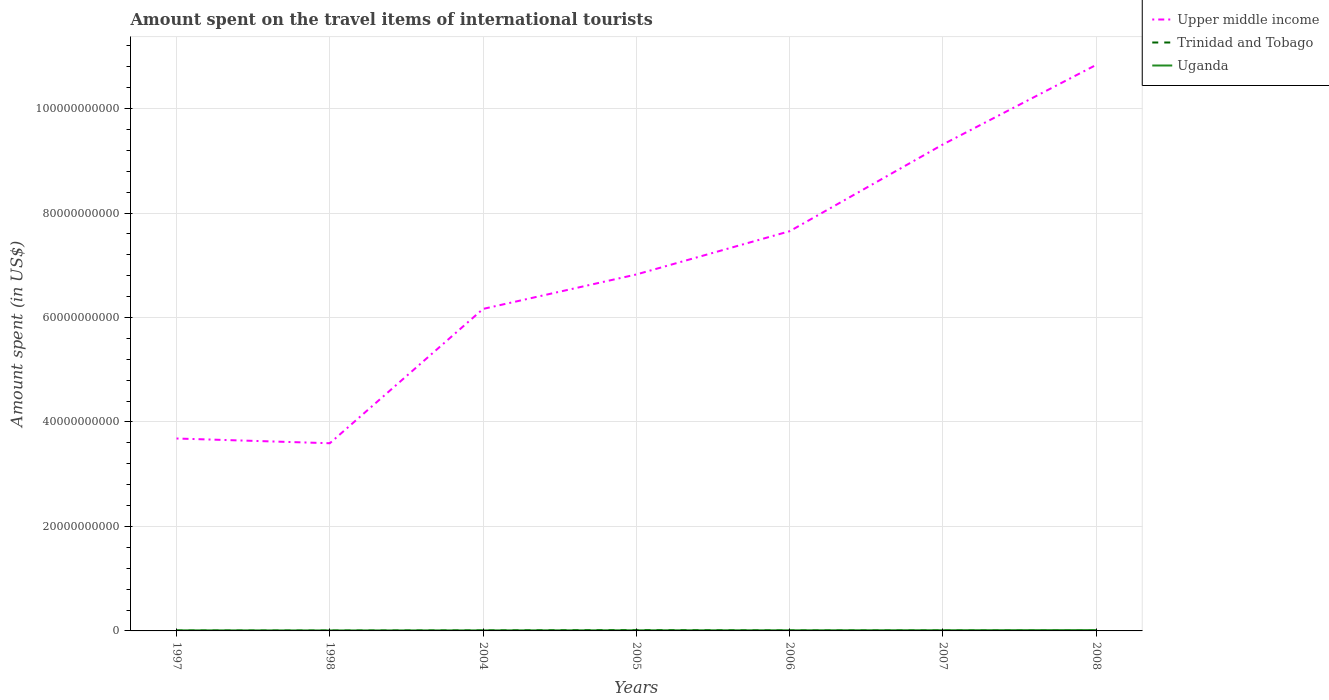Does the line corresponding to Trinidad and Tobago intersect with the line corresponding to Upper middle income?
Your response must be concise. No. Across all years, what is the maximum amount spent on the travel items of international tourists in Upper middle income?
Ensure brevity in your answer.  3.59e+1. In which year was the amount spent on the travel items of international tourists in Uganda maximum?
Your answer should be very brief. 1998. What is the total amount spent on the travel items of international tourists in Upper middle income in the graph?
Your answer should be compact. -5.72e+1. What is the difference between the highest and the second highest amount spent on the travel items of international tourists in Upper middle income?
Your answer should be compact. 7.24e+1. What is the difference between the highest and the lowest amount spent on the travel items of international tourists in Upper middle income?
Provide a short and direct response. 3. Is the amount spent on the travel items of international tourists in Uganda strictly greater than the amount spent on the travel items of international tourists in Upper middle income over the years?
Ensure brevity in your answer.  Yes. How many lines are there?
Your answer should be very brief. 3. Are the values on the major ticks of Y-axis written in scientific E-notation?
Your answer should be compact. No. Where does the legend appear in the graph?
Provide a succinct answer. Top right. What is the title of the graph?
Your response must be concise. Amount spent on the travel items of international tourists. Does "Luxembourg" appear as one of the legend labels in the graph?
Your answer should be very brief. No. What is the label or title of the Y-axis?
Give a very brief answer. Amount spent (in US$). What is the Amount spent (in US$) in Upper middle income in 1997?
Your answer should be very brief. 3.68e+1. What is the Amount spent (in US$) in Trinidad and Tobago in 1997?
Ensure brevity in your answer.  7.20e+07. What is the Amount spent (in US$) in Uganda in 1997?
Keep it short and to the point. 1.13e+08. What is the Amount spent (in US$) of Upper middle income in 1998?
Provide a short and direct response. 3.59e+1. What is the Amount spent (in US$) of Trinidad and Tobago in 1998?
Give a very brief answer. 6.70e+07. What is the Amount spent (in US$) of Uganda in 1998?
Offer a terse response. 9.50e+07. What is the Amount spent (in US$) of Upper middle income in 2004?
Keep it short and to the point. 6.16e+1. What is the Amount spent (in US$) in Trinidad and Tobago in 2004?
Ensure brevity in your answer.  9.60e+07. What is the Amount spent (in US$) in Uganda in 2004?
Your answer should be compact. 1.08e+08. What is the Amount spent (in US$) in Upper middle income in 2005?
Offer a terse response. 6.82e+1. What is the Amount spent (in US$) of Trinidad and Tobago in 2005?
Make the answer very short. 1.80e+08. What is the Amount spent (in US$) in Uganda in 2005?
Your answer should be compact. 1.24e+08. What is the Amount spent (in US$) in Upper middle income in 2006?
Your response must be concise. 7.65e+1. What is the Amount spent (in US$) of Trinidad and Tobago in 2006?
Make the answer very short. 9.30e+07. What is the Amount spent (in US$) of Uganda in 2006?
Your answer should be compact. 1.23e+08. What is the Amount spent (in US$) of Upper middle income in 2007?
Provide a succinct answer. 9.31e+1. What is the Amount spent (in US$) in Trinidad and Tobago in 2007?
Give a very brief answer. 9.40e+07. What is the Amount spent (in US$) of Uganda in 2007?
Offer a very short reply. 1.32e+08. What is the Amount spent (in US$) of Upper middle income in 2008?
Keep it short and to the point. 1.08e+11. What is the Amount spent (in US$) of Trinidad and Tobago in 2008?
Your answer should be compact. 7.50e+07. What is the Amount spent (in US$) in Uganda in 2008?
Your answer should be very brief. 1.56e+08. Across all years, what is the maximum Amount spent (in US$) of Upper middle income?
Your answer should be very brief. 1.08e+11. Across all years, what is the maximum Amount spent (in US$) of Trinidad and Tobago?
Keep it short and to the point. 1.80e+08. Across all years, what is the maximum Amount spent (in US$) of Uganda?
Your answer should be compact. 1.56e+08. Across all years, what is the minimum Amount spent (in US$) of Upper middle income?
Your answer should be very brief. 3.59e+1. Across all years, what is the minimum Amount spent (in US$) of Trinidad and Tobago?
Keep it short and to the point. 6.70e+07. Across all years, what is the minimum Amount spent (in US$) of Uganda?
Your response must be concise. 9.50e+07. What is the total Amount spent (in US$) in Upper middle income in the graph?
Offer a terse response. 4.81e+11. What is the total Amount spent (in US$) of Trinidad and Tobago in the graph?
Provide a short and direct response. 6.77e+08. What is the total Amount spent (in US$) in Uganda in the graph?
Provide a succinct answer. 8.51e+08. What is the difference between the Amount spent (in US$) of Upper middle income in 1997 and that in 1998?
Offer a terse response. 9.09e+08. What is the difference between the Amount spent (in US$) of Trinidad and Tobago in 1997 and that in 1998?
Provide a short and direct response. 5.00e+06. What is the difference between the Amount spent (in US$) of Uganda in 1997 and that in 1998?
Provide a succinct answer. 1.80e+07. What is the difference between the Amount spent (in US$) of Upper middle income in 1997 and that in 2004?
Give a very brief answer. -2.48e+1. What is the difference between the Amount spent (in US$) in Trinidad and Tobago in 1997 and that in 2004?
Provide a succinct answer. -2.40e+07. What is the difference between the Amount spent (in US$) in Uganda in 1997 and that in 2004?
Your answer should be very brief. 5.00e+06. What is the difference between the Amount spent (in US$) of Upper middle income in 1997 and that in 2005?
Ensure brevity in your answer.  -3.14e+1. What is the difference between the Amount spent (in US$) of Trinidad and Tobago in 1997 and that in 2005?
Provide a short and direct response. -1.08e+08. What is the difference between the Amount spent (in US$) of Uganda in 1997 and that in 2005?
Offer a terse response. -1.10e+07. What is the difference between the Amount spent (in US$) of Upper middle income in 1997 and that in 2006?
Ensure brevity in your answer.  -3.97e+1. What is the difference between the Amount spent (in US$) of Trinidad and Tobago in 1997 and that in 2006?
Make the answer very short. -2.10e+07. What is the difference between the Amount spent (in US$) of Uganda in 1997 and that in 2006?
Offer a very short reply. -1.00e+07. What is the difference between the Amount spent (in US$) in Upper middle income in 1997 and that in 2007?
Ensure brevity in your answer.  -5.63e+1. What is the difference between the Amount spent (in US$) in Trinidad and Tobago in 1997 and that in 2007?
Your response must be concise. -2.20e+07. What is the difference between the Amount spent (in US$) of Uganda in 1997 and that in 2007?
Keep it short and to the point. -1.90e+07. What is the difference between the Amount spent (in US$) of Upper middle income in 1997 and that in 2008?
Your answer should be very brief. -7.15e+1. What is the difference between the Amount spent (in US$) of Trinidad and Tobago in 1997 and that in 2008?
Ensure brevity in your answer.  -3.00e+06. What is the difference between the Amount spent (in US$) of Uganda in 1997 and that in 2008?
Your answer should be very brief. -4.30e+07. What is the difference between the Amount spent (in US$) in Upper middle income in 1998 and that in 2004?
Give a very brief answer. -2.57e+1. What is the difference between the Amount spent (in US$) of Trinidad and Tobago in 1998 and that in 2004?
Make the answer very short. -2.90e+07. What is the difference between the Amount spent (in US$) in Uganda in 1998 and that in 2004?
Make the answer very short. -1.30e+07. What is the difference between the Amount spent (in US$) in Upper middle income in 1998 and that in 2005?
Offer a terse response. -3.23e+1. What is the difference between the Amount spent (in US$) in Trinidad and Tobago in 1998 and that in 2005?
Your answer should be very brief. -1.13e+08. What is the difference between the Amount spent (in US$) of Uganda in 1998 and that in 2005?
Offer a very short reply. -2.90e+07. What is the difference between the Amount spent (in US$) of Upper middle income in 1998 and that in 2006?
Give a very brief answer. -4.06e+1. What is the difference between the Amount spent (in US$) in Trinidad and Tobago in 1998 and that in 2006?
Provide a succinct answer. -2.60e+07. What is the difference between the Amount spent (in US$) of Uganda in 1998 and that in 2006?
Give a very brief answer. -2.80e+07. What is the difference between the Amount spent (in US$) in Upper middle income in 1998 and that in 2007?
Your answer should be compact. -5.72e+1. What is the difference between the Amount spent (in US$) in Trinidad and Tobago in 1998 and that in 2007?
Keep it short and to the point. -2.70e+07. What is the difference between the Amount spent (in US$) in Uganda in 1998 and that in 2007?
Give a very brief answer. -3.70e+07. What is the difference between the Amount spent (in US$) in Upper middle income in 1998 and that in 2008?
Your response must be concise. -7.24e+1. What is the difference between the Amount spent (in US$) in Trinidad and Tobago in 1998 and that in 2008?
Your response must be concise. -8.00e+06. What is the difference between the Amount spent (in US$) in Uganda in 1998 and that in 2008?
Provide a short and direct response. -6.10e+07. What is the difference between the Amount spent (in US$) in Upper middle income in 2004 and that in 2005?
Provide a short and direct response. -6.59e+09. What is the difference between the Amount spent (in US$) of Trinidad and Tobago in 2004 and that in 2005?
Make the answer very short. -8.40e+07. What is the difference between the Amount spent (in US$) of Uganda in 2004 and that in 2005?
Offer a very short reply. -1.60e+07. What is the difference between the Amount spent (in US$) of Upper middle income in 2004 and that in 2006?
Offer a very short reply. -1.49e+1. What is the difference between the Amount spent (in US$) in Uganda in 2004 and that in 2006?
Give a very brief answer. -1.50e+07. What is the difference between the Amount spent (in US$) of Upper middle income in 2004 and that in 2007?
Your answer should be very brief. -3.15e+1. What is the difference between the Amount spent (in US$) of Uganda in 2004 and that in 2007?
Provide a short and direct response. -2.40e+07. What is the difference between the Amount spent (in US$) in Upper middle income in 2004 and that in 2008?
Offer a very short reply. -4.67e+1. What is the difference between the Amount spent (in US$) in Trinidad and Tobago in 2004 and that in 2008?
Your response must be concise. 2.10e+07. What is the difference between the Amount spent (in US$) of Uganda in 2004 and that in 2008?
Offer a very short reply. -4.80e+07. What is the difference between the Amount spent (in US$) of Upper middle income in 2005 and that in 2006?
Provide a succinct answer. -8.28e+09. What is the difference between the Amount spent (in US$) in Trinidad and Tobago in 2005 and that in 2006?
Ensure brevity in your answer.  8.70e+07. What is the difference between the Amount spent (in US$) in Uganda in 2005 and that in 2006?
Your response must be concise. 1.00e+06. What is the difference between the Amount spent (in US$) of Upper middle income in 2005 and that in 2007?
Offer a terse response. -2.49e+1. What is the difference between the Amount spent (in US$) in Trinidad and Tobago in 2005 and that in 2007?
Give a very brief answer. 8.60e+07. What is the difference between the Amount spent (in US$) of Uganda in 2005 and that in 2007?
Give a very brief answer. -8.00e+06. What is the difference between the Amount spent (in US$) in Upper middle income in 2005 and that in 2008?
Your answer should be compact. -4.01e+1. What is the difference between the Amount spent (in US$) of Trinidad and Tobago in 2005 and that in 2008?
Your answer should be compact. 1.05e+08. What is the difference between the Amount spent (in US$) of Uganda in 2005 and that in 2008?
Your response must be concise. -3.20e+07. What is the difference between the Amount spent (in US$) of Upper middle income in 2006 and that in 2007?
Offer a very short reply. -1.66e+1. What is the difference between the Amount spent (in US$) of Trinidad and Tobago in 2006 and that in 2007?
Provide a succinct answer. -1.00e+06. What is the difference between the Amount spent (in US$) of Uganda in 2006 and that in 2007?
Provide a succinct answer. -9.00e+06. What is the difference between the Amount spent (in US$) in Upper middle income in 2006 and that in 2008?
Offer a very short reply. -3.18e+1. What is the difference between the Amount spent (in US$) in Trinidad and Tobago in 2006 and that in 2008?
Offer a very short reply. 1.80e+07. What is the difference between the Amount spent (in US$) in Uganda in 2006 and that in 2008?
Keep it short and to the point. -3.30e+07. What is the difference between the Amount spent (in US$) of Upper middle income in 2007 and that in 2008?
Offer a very short reply. -1.52e+1. What is the difference between the Amount spent (in US$) in Trinidad and Tobago in 2007 and that in 2008?
Your response must be concise. 1.90e+07. What is the difference between the Amount spent (in US$) of Uganda in 2007 and that in 2008?
Your response must be concise. -2.40e+07. What is the difference between the Amount spent (in US$) in Upper middle income in 1997 and the Amount spent (in US$) in Trinidad and Tobago in 1998?
Offer a terse response. 3.68e+1. What is the difference between the Amount spent (in US$) in Upper middle income in 1997 and the Amount spent (in US$) in Uganda in 1998?
Keep it short and to the point. 3.67e+1. What is the difference between the Amount spent (in US$) of Trinidad and Tobago in 1997 and the Amount spent (in US$) of Uganda in 1998?
Your answer should be very brief. -2.30e+07. What is the difference between the Amount spent (in US$) in Upper middle income in 1997 and the Amount spent (in US$) in Trinidad and Tobago in 2004?
Make the answer very short. 3.67e+1. What is the difference between the Amount spent (in US$) in Upper middle income in 1997 and the Amount spent (in US$) in Uganda in 2004?
Provide a succinct answer. 3.67e+1. What is the difference between the Amount spent (in US$) in Trinidad and Tobago in 1997 and the Amount spent (in US$) in Uganda in 2004?
Give a very brief answer. -3.60e+07. What is the difference between the Amount spent (in US$) of Upper middle income in 1997 and the Amount spent (in US$) of Trinidad and Tobago in 2005?
Ensure brevity in your answer.  3.67e+1. What is the difference between the Amount spent (in US$) in Upper middle income in 1997 and the Amount spent (in US$) in Uganda in 2005?
Your response must be concise. 3.67e+1. What is the difference between the Amount spent (in US$) in Trinidad and Tobago in 1997 and the Amount spent (in US$) in Uganda in 2005?
Your response must be concise. -5.20e+07. What is the difference between the Amount spent (in US$) in Upper middle income in 1997 and the Amount spent (in US$) in Trinidad and Tobago in 2006?
Give a very brief answer. 3.67e+1. What is the difference between the Amount spent (in US$) of Upper middle income in 1997 and the Amount spent (in US$) of Uganda in 2006?
Offer a very short reply. 3.67e+1. What is the difference between the Amount spent (in US$) of Trinidad and Tobago in 1997 and the Amount spent (in US$) of Uganda in 2006?
Your response must be concise. -5.10e+07. What is the difference between the Amount spent (in US$) of Upper middle income in 1997 and the Amount spent (in US$) of Trinidad and Tobago in 2007?
Offer a terse response. 3.67e+1. What is the difference between the Amount spent (in US$) in Upper middle income in 1997 and the Amount spent (in US$) in Uganda in 2007?
Offer a very short reply. 3.67e+1. What is the difference between the Amount spent (in US$) of Trinidad and Tobago in 1997 and the Amount spent (in US$) of Uganda in 2007?
Your answer should be very brief. -6.00e+07. What is the difference between the Amount spent (in US$) of Upper middle income in 1997 and the Amount spent (in US$) of Trinidad and Tobago in 2008?
Keep it short and to the point. 3.68e+1. What is the difference between the Amount spent (in US$) of Upper middle income in 1997 and the Amount spent (in US$) of Uganda in 2008?
Ensure brevity in your answer.  3.67e+1. What is the difference between the Amount spent (in US$) of Trinidad and Tobago in 1997 and the Amount spent (in US$) of Uganda in 2008?
Your answer should be very brief. -8.40e+07. What is the difference between the Amount spent (in US$) of Upper middle income in 1998 and the Amount spent (in US$) of Trinidad and Tobago in 2004?
Keep it short and to the point. 3.58e+1. What is the difference between the Amount spent (in US$) of Upper middle income in 1998 and the Amount spent (in US$) of Uganda in 2004?
Keep it short and to the point. 3.58e+1. What is the difference between the Amount spent (in US$) of Trinidad and Tobago in 1998 and the Amount spent (in US$) of Uganda in 2004?
Provide a short and direct response. -4.10e+07. What is the difference between the Amount spent (in US$) of Upper middle income in 1998 and the Amount spent (in US$) of Trinidad and Tobago in 2005?
Your response must be concise. 3.57e+1. What is the difference between the Amount spent (in US$) in Upper middle income in 1998 and the Amount spent (in US$) in Uganda in 2005?
Make the answer very short. 3.58e+1. What is the difference between the Amount spent (in US$) in Trinidad and Tobago in 1998 and the Amount spent (in US$) in Uganda in 2005?
Make the answer very short. -5.70e+07. What is the difference between the Amount spent (in US$) of Upper middle income in 1998 and the Amount spent (in US$) of Trinidad and Tobago in 2006?
Ensure brevity in your answer.  3.58e+1. What is the difference between the Amount spent (in US$) of Upper middle income in 1998 and the Amount spent (in US$) of Uganda in 2006?
Your response must be concise. 3.58e+1. What is the difference between the Amount spent (in US$) of Trinidad and Tobago in 1998 and the Amount spent (in US$) of Uganda in 2006?
Give a very brief answer. -5.60e+07. What is the difference between the Amount spent (in US$) of Upper middle income in 1998 and the Amount spent (in US$) of Trinidad and Tobago in 2007?
Your answer should be very brief. 3.58e+1. What is the difference between the Amount spent (in US$) in Upper middle income in 1998 and the Amount spent (in US$) in Uganda in 2007?
Your response must be concise. 3.58e+1. What is the difference between the Amount spent (in US$) in Trinidad and Tobago in 1998 and the Amount spent (in US$) in Uganda in 2007?
Your answer should be very brief. -6.50e+07. What is the difference between the Amount spent (in US$) of Upper middle income in 1998 and the Amount spent (in US$) of Trinidad and Tobago in 2008?
Your answer should be compact. 3.59e+1. What is the difference between the Amount spent (in US$) in Upper middle income in 1998 and the Amount spent (in US$) in Uganda in 2008?
Ensure brevity in your answer.  3.58e+1. What is the difference between the Amount spent (in US$) of Trinidad and Tobago in 1998 and the Amount spent (in US$) of Uganda in 2008?
Give a very brief answer. -8.90e+07. What is the difference between the Amount spent (in US$) of Upper middle income in 2004 and the Amount spent (in US$) of Trinidad and Tobago in 2005?
Offer a very short reply. 6.15e+1. What is the difference between the Amount spent (in US$) in Upper middle income in 2004 and the Amount spent (in US$) in Uganda in 2005?
Give a very brief answer. 6.15e+1. What is the difference between the Amount spent (in US$) in Trinidad and Tobago in 2004 and the Amount spent (in US$) in Uganda in 2005?
Your answer should be very brief. -2.80e+07. What is the difference between the Amount spent (in US$) of Upper middle income in 2004 and the Amount spent (in US$) of Trinidad and Tobago in 2006?
Provide a short and direct response. 6.15e+1. What is the difference between the Amount spent (in US$) in Upper middle income in 2004 and the Amount spent (in US$) in Uganda in 2006?
Offer a very short reply. 6.15e+1. What is the difference between the Amount spent (in US$) in Trinidad and Tobago in 2004 and the Amount spent (in US$) in Uganda in 2006?
Your answer should be compact. -2.70e+07. What is the difference between the Amount spent (in US$) in Upper middle income in 2004 and the Amount spent (in US$) in Trinidad and Tobago in 2007?
Give a very brief answer. 6.15e+1. What is the difference between the Amount spent (in US$) of Upper middle income in 2004 and the Amount spent (in US$) of Uganda in 2007?
Ensure brevity in your answer.  6.15e+1. What is the difference between the Amount spent (in US$) of Trinidad and Tobago in 2004 and the Amount spent (in US$) of Uganda in 2007?
Keep it short and to the point. -3.60e+07. What is the difference between the Amount spent (in US$) in Upper middle income in 2004 and the Amount spent (in US$) in Trinidad and Tobago in 2008?
Ensure brevity in your answer.  6.16e+1. What is the difference between the Amount spent (in US$) in Upper middle income in 2004 and the Amount spent (in US$) in Uganda in 2008?
Make the answer very short. 6.15e+1. What is the difference between the Amount spent (in US$) of Trinidad and Tobago in 2004 and the Amount spent (in US$) of Uganda in 2008?
Offer a very short reply. -6.00e+07. What is the difference between the Amount spent (in US$) of Upper middle income in 2005 and the Amount spent (in US$) of Trinidad and Tobago in 2006?
Ensure brevity in your answer.  6.81e+1. What is the difference between the Amount spent (in US$) in Upper middle income in 2005 and the Amount spent (in US$) in Uganda in 2006?
Your answer should be very brief. 6.81e+1. What is the difference between the Amount spent (in US$) in Trinidad and Tobago in 2005 and the Amount spent (in US$) in Uganda in 2006?
Offer a terse response. 5.70e+07. What is the difference between the Amount spent (in US$) in Upper middle income in 2005 and the Amount spent (in US$) in Trinidad and Tobago in 2007?
Give a very brief answer. 6.81e+1. What is the difference between the Amount spent (in US$) in Upper middle income in 2005 and the Amount spent (in US$) in Uganda in 2007?
Provide a succinct answer. 6.81e+1. What is the difference between the Amount spent (in US$) in Trinidad and Tobago in 2005 and the Amount spent (in US$) in Uganda in 2007?
Your response must be concise. 4.80e+07. What is the difference between the Amount spent (in US$) in Upper middle income in 2005 and the Amount spent (in US$) in Trinidad and Tobago in 2008?
Your answer should be very brief. 6.82e+1. What is the difference between the Amount spent (in US$) in Upper middle income in 2005 and the Amount spent (in US$) in Uganda in 2008?
Your response must be concise. 6.81e+1. What is the difference between the Amount spent (in US$) in Trinidad and Tobago in 2005 and the Amount spent (in US$) in Uganda in 2008?
Offer a terse response. 2.40e+07. What is the difference between the Amount spent (in US$) in Upper middle income in 2006 and the Amount spent (in US$) in Trinidad and Tobago in 2007?
Give a very brief answer. 7.64e+1. What is the difference between the Amount spent (in US$) of Upper middle income in 2006 and the Amount spent (in US$) of Uganda in 2007?
Make the answer very short. 7.64e+1. What is the difference between the Amount spent (in US$) of Trinidad and Tobago in 2006 and the Amount spent (in US$) of Uganda in 2007?
Provide a short and direct response. -3.90e+07. What is the difference between the Amount spent (in US$) of Upper middle income in 2006 and the Amount spent (in US$) of Trinidad and Tobago in 2008?
Keep it short and to the point. 7.64e+1. What is the difference between the Amount spent (in US$) in Upper middle income in 2006 and the Amount spent (in US$) in Uganda in 2008?
Your response must be concise. 7.64e+1. What is the difference between the Amount spent (in US$) in Trinidad and Tobago in 2006 and the Amount spent (in US$) in Uganda in 2008?
Make the answer very short. -6.30e+07. What is the difference between the Amount spent (in US$) of Upper middle income in 2007 and the Amount spent (in US$) of Trinidad and Tobago in 2008?
Offer a terse response. 9.31e+1. What is the difference between the Amount spent (in US$) of Upper middle income in 2007 and the Amount spent (in US$) of Uganda in 2008?
Provide a succinct answer. 9.30e+1. What is the difference between the Amount spent (in US$) in Trinidad and Tobago in 2007 and the Amount spent (in US$) in Uganda in 2008?
Provide a short and direct response. -6.20e+07. What is the average Amount spent (in US$) in Upper middle income per year?
Provide a succinct answer. 6.87e+1. What is the average Amount spent (in US$) in Trinidad and Tobago per year?
Ensure brevity in your answer.  9.67e+07. What is the average Amount spent (in US$) in Uganda per year?
Provide a succinct answer. 1.22e+08. In the year 1997, what is the difference between the Amount spent (in US$) in Upper middle income and Amount spent (in US$) in Trinidad and Tobago?
Your answer should be very brief. 3.68e+1. In the year 1997, what is the difference between the Amount spent (in US$) of Upper middle income and Amount spent (in US$) of Uganda?
Your response must be concise. 3.67e+1. In the year 1997, what is the difference between the Amount spent (in US$) of Trinidad and Tobago and Amount spent (in US$) of Uganda?
Give a very brief answer. -4.10e+07. In the year 1998, what is the difference between the Amount spent (in US$) of Upper middle income and Amount spent (in US$) of Trinidad and Tobago?
Your answer should be compact. 3.59e+1. In the year 1998, what is the difference between the Amount spent (in US$) of Upper middle income and Amount spent (in US$) of Uganda?
Keep it short and to the point. 3.58e+1. In the year 1998, what is the difference between the Amount spent (in US$) in Trinidad and Tobago and Amount spent (in US$) in Uganda?
Your answer should be compact. -2.80e+07. In the year 2004, what is the difference between the Amount spent (in US$) of Upper middle income and Amount spent (in US$) of Trinidad and Tobago?
Your answer should be very brief. 6.15e+1. In the year 2004, what is the difference between the Amount spent (in US$) in Upper middle income and Amount spent (in US$) in Uganda?
Ensure brevity in your answer.  6.15e+1. In the year 2004, what is the difference between the Amount spent (in US$) of Trinidad and Tobago and Amount spent (in US$) of Uganda?
Ensure brevity in your answer.  -1.20e+07. In the year 2005, what is the difference between the Amount spent (in US$) in Upper middle income and Amount spent (in US$) in Trinidad and Tobago?
Your answer should be very brief. 6.81e+1. In the year 2005, what is the difference between the Amount spent (in US$) in Upper middle income and Amount spent (in US$) in Uganda?
Keep it short and to the point. 6.81e+1. In the year 2005, what is the difference between the Amount spent (in US$) of Trinidad and Tobago and Amount spent (in US$) of Uganda?
Provide a succinct answer. 5.60e+07. In the year 2006, what is the difference between the Amount spent (in US$) in Upper middle income and Amount spent (in US$) in Trinidad and Tobago?
Your answer should be very brief. 7.64e+1. In the year 2006, what is the difference between the Amount spent (in US$) in Upper middle income and Amount spent (in US$) in Uganda?
Keep it short and to the point. 7.64e+1. In the year 2006, what is the difference between the Amount spent (in US$) of Trinidad and Tobago and Amount spent (in US$) of Uganda?
Provide a succinct answer. -3.00e+07. In the year 2007, what is the difference between the Amount spent (in US$) of Upper middle income and Amount spent (in US$) of Trinidad and Tobago?
Offer a very short reply. 9.30e+1. In the year 2007, what is the difference between the Amount spent (in US$) in Upper middle income and Amount spent (in US$) in Uganda?
Give a very brief answer. 9.30e+1. In the year 2007, what is the difference between the Amount spent (in US$) in Trinidad and Tobago and Amount spent (in US$) in Uganda?
Offer a very short reply. -3.80e+07. In the year 2008, what is the difference between the Amount spent (in US$) of Upper middle income and Amount spent (in US$) of Trinidad and Tobago?
Your response must be concise. 1.08e+11. In the year 2008, what is the difference between the Amount spent (in US$) in Upper middle income and Amount spent (in US$) in Uganda?
Give a very brief answer. 1.08e+11. In the year 2008, what is the difference between the Amount spent (in US$) in Trinidad and Tobago and Amount spent (in US$) in Uganda?
Your answer should be compact. -8.10e+07. What is the ratio of the Amount spent (in US$) in Upper middle income in 1997 to that in 1998?
Ensure brevity in your answer.  1.03. What is the ratio of the Amount spent (in US$) in Trinidad and Tobago in 1997 to that in 1998?
Your answer should be compact. 1.07. What is the ratio of the Amount spent (in US$) of Uganda in 1997 to that in 1998?
Your answer should be compact. 1.19. What is the ratio of the Amount spent (in US$) in Upper middle income in 1997 to that in 2004?
Offer a terse response. 0.6. What is the ratio of the Amount spent (in US$) in Trinidad and Tobago in 1997 to that in 2004?
Offer a terse response. 0.75. What is the ratio of the Amount spent (in US$) of Uganda in 1997 to that in 2004?
Offer a very short reply. 1.05. What is the ratio of the Amount spent (in US$) in Upper middle income in 1997 to that in 2005?
Provide a short and direct response. 0.54. What is the ratio of the Amount spent (in US$) in Uganda in 1997 to that in 2005?
Make the answer very short. 0.91. What is the ratio of the Amount spent (in US$) in Upper middle income in 1997 to that in 2006?
Make the answer very short. 0.48. What is the ratio of the Amount spent (in US$) in Trinidad and Tobago in 1997 to that in 2006?
Offer a terse response. 0.77. What is the ratio of the Amount spent (in US$) in Uganda in 1997 to that in 2006?
Offer a very short reply. 0.92. What is the ratio of the Amount spent (in US$) of Upper middle income in 1997 to that in 2007?
Make the answer very short. 0.4. What is the ratio of the Amount spent (in US$) in Trinidad and Tobago in 1997 to that in 2007?
Provide a succinct answer. 0.77. What is the ratio of the Amount spent (in US$) of Uganda in 1997 to that in 2007?
Give a very brief answer. 0.86. What is the ratio of the Amount spent (in US$) of Upper middle income in 1997 to that in 2008?
Your answer should be very brief. 0.34. What is the ratio of the Amount spent (in US$) in Trinidad and Tobago in 1997 to that in 2008?
Your answer should be very brief. 0.96. What is the ratio of the Amount spent (in US$) of Uganda in 1997 to that in 2008?
Offer a terse response. 0.72. What is the ratio of the Amount spent (in US$) in Upper middle income in 1998 to that in 2004?
Offer a terse response. 0.58. What is the ratio of the Amount spent (in US$) in Trinidad and Tobago in 1998 to that in 2004?
Your answer should be compact. 0.7. What is the ratio of the Amount spent (in US$) of Uganda in 1998 to that in 2004?
Your response must be concise. 0.88. What is the ratio of the Amount spent (in US$) in Upper middle income in 1998 to that in 2005?
Your answer should be very brief. 0.53. What is the ratio of the Amount spent (in US$) of Trinidad and Tobago in 1998 to that in 2005?
Offer a very short reply. 0.37. What is the ratio of the Amount spent (in US$) in Uganda in 1998 to that in 2005?
Your answer should be compact. 0.77. What is the ratio of the Amount spent (in US$) in Upper middle income in 1998 to that in 2006?
Provide a short and direct response. 0.47. What is the ratio of the Amount spent (in US$) in Trinidad and Tobago in 1998 to that in 2006?
Provide a succinct answer. 0.72. What is the ratio of the Amount spent (in US$) in Uganda in 1998 to that in 2006?
Your response must be concise. 0.77. What is the ratio of the Amount spent (in US$) in Upper middle income in 1998 to that in 2007?
Your answer should be very brief. 0.39. What is the ratio of the Amount spent (in US$) of Trinidad and Tobago in 1998 to that in 2007?
Offer a terse response. 0.71. What is the ratio of the Amount spent (in US$) in Uganda in 1998 to that in 2007?
Offer a very short reply. 0.72. What is the ratio of the Amount spent (in US$) of Upper middle income in 1998 to that in 2008?
Give a very brief answer. 0.33. What is the ratio of the Amount spent (in US$) of Trinidad and Tobago in 1998 to that in 2008?
Your answer should be very brief. 0.89. What is the ratio of the Amount spent (in US$) of Uganda in 1998 to that in 2008?
Provide a short and direct response. 0.61. What is the ratio of the Amount spent (in US$) of Upper middle income in 2004 to that in 2005?
Offer a terse response. 0.9. What is the ratio of the Amount spent (in US$) of Trinidad and Tobago in 2004 to that in 2005?
Give a very brief answer. 0.53. What is the ratio of the Amount spent (in US$) of Uganda in 2004 to that in 2005?
Make the answer very short. 0.87. What is the ratio of the Amount spent (in US$) of Upper middle income in 2004 to that in 2006?
Your response must be concise. 0.81. What is the ratio of the Amount spent (in US$) in Trinidad and Tobago in 2004 to that in 2006?
Offer a very short reply. 1.03. What is the ratio of the Amount spent (in US$) in Uganda in 2004 to that in 2006?
Provide a succinct answer. 0.88. What is the ratio of the Amount spent (in US$) in Upper middle income in 2004 to that in 2007?
Provide a succinct answer. 0.66. What is the ratio of the Amount spent (in US$) of Trinidad and Tobago in 2004 to that in 2007?
Provide a succinct answer. 1.02. What is the ratio of the Amount spent (in US$) in Uganda in 2004 to that in 2007?
Your response must be concise. 0.82. What is the ratio of the Amount spent (in US$) in Upper middle income in 2004 to that in 2008?
Provide a succinct answer. 0.57. What is the ratio of the Amount spent (in US$) in Trinidad and Tobago in 2004 to that in 2008?
Give a very brief answer. 1.28. What is the ratio of the Amount spent (in US$) of Uganda in 2004 to that in 2008?
Your answer should be very brief. 0.69. What is the ratio of the Amount spent (in US$) of Upper middle income in 2005 to that in 2006?
Keep it short and to the point. 0.89. What is the ratio of the Amount spent (in US$) in Trinidad and Tobago in 2005 to that in 2006?
Make the answer very short. 1.94. What is the ratio of the Amount spent (in US$) in Upper middle income in 2005 to that in 2007?
Offer a terse response. 0.73. What is the ratio of the Amount spent (in US$) of Trinidad and Tobago in 2005 to that in 2007?
Give a very brief answer. 1.91. What is the ratio of the Amount spent (in US$) in Uganda in 2005 to that in 2007?
Offer a very short reply. 0.94. What is the ratio of the Amount spent (in US$) in Upper middle income in 2005 to that in 2008?
Offer a terse response. 0.63. What is the ratio of the Amount spent (in US$) in Trinidad and Tobago in 2005 to that in 2008?
Give a very brief answer. 2.4. What is the ratio of the Amount spent (in US$) in Uganda in 2005 to that in 2008?
Keep it short and to the point. 0.79. What is the ratio of the Amount spent (in US$) of Upper middle income in 2006 to that in 2007?
Ensure brevity in your answer.  0.82. What is the ratio of the Amount spent (in US$) in Trinidad and Tobago in 2006 to that in 2007?
Your response must be concise. 0.99. What is the ratio of the Amount spent (in US$) in Uganda in 2006 to that in 2007?
Your answer should be very brief. 0.93. What is the ratio of the Amount spent (in US$) of Upper middle income in 2006 to that in 2008?
Ensure brevity in your answer.  0.71. What is the ratio of the Amount spent (in US$) in Trinidad and Tobago in 2006 to that in 2008?
Make the answer very short. 1.24. What is the ratio of the Amount spent (in US$) of Uganda in 2006 to that in 2008?
Your response must be concise. 0.79. What is the ratio of the Amount spent (in US$) in Upper middle income in 2007 to that in 2008?
Offer a terse response. 0.86. What is the ratio of the Amount spent (in US$) in Trinidad and Tobago in 2007 to that in 2008?
Offer a very short reply. 1.25. What is the ratio of the Amount spent (in US$) of Uganda in 2007 to that in 2008?
Provide a short and direct response. 0.85. What is the difference between the highest and the second highest Amount spent (in US$) in Upper middle income?
Keep it short and to the point. 1.52e+1. What is the difference between the highest and the second highest Amount spent (in US$) of Trinidad and Tobago?
Offer a very short reply. 8.40e+07. What is the difference between the highest and the second highest Amount spent (in US$) of Uganda?
Give a very brief answer. 2.40e+07. What is the difference between the highest and the lowest Amount spent (in US$) in Upper middle income?
Ensure brevity in your answer.  7.24e+1. What is the difference between the highest and the lowest Amount spent (in US$) in Trinidad and Tobago?
Provide a short and direct response. 1.13e+08. What is the difference between the highest and the lowest Amount spent (in US$) in Uganda?
Provide a succinct answer. 6.10e+07. 